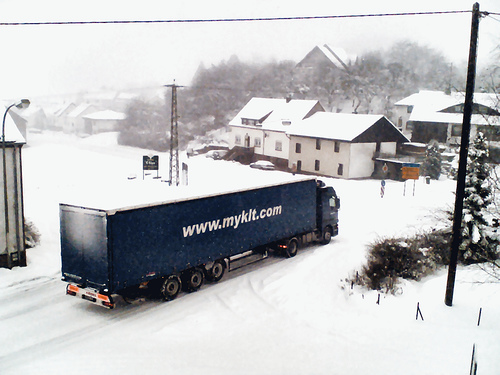How many tires can be seen? Based on the visible parts of the truck in the image, at least 6 tires can be discerned from the side facing the camera - 2 at the front of the truck and 4 on the rear axle. However, it's common for trucks to have additional tires on the other side, so there may be more tires that are not visible in this image. 